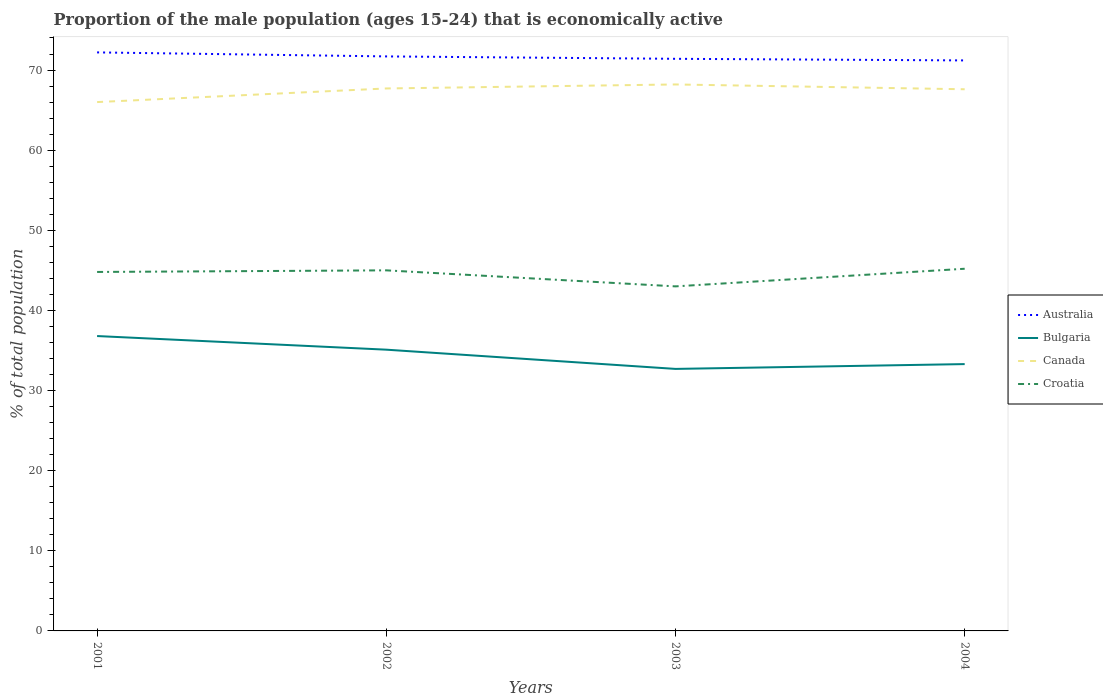How many different coloured lines are there?
Offer a very short reply. 4. Is the number of lines equal to the number of legend labels?
Offer a very short reply. Yes. Across all years, what is the maximum proportion of the male population that is economically active in Australia?
Offer a terse response. 71.2. What is the total proportion of the male population that is economically active in Australia in the graph?
Keep it short and to the point. 0.2. What is the difference between the highest and the second highest proportion of the male population that is economically active in Croatia?
Keep it short and to the point. 2.2. How many lines are there?
Offer a terse response. 4. How many years are there in the graph?
Ensure brevity in your answer.  4. Where does the legend appear in the graph?
Make the answer very short. Center right. What is the title of the graph?
Make the answer very short. Proportion of the male population (ages 15-24) that is economically active. What is the label or title of the X-axis?
Your answer should be very brief. Years. What is the label or title of the Y-axis?
Give a very brief answer. % of total population. What is the % of total population of Australia in 2001?
Give a very brief answer. 72.2. What is the % of total population in Bulgaria in 2001?
Ensure brevity in your answer.  36.8. What is the % of total population of Canada in 2001?
Provide a succinct answer. 66. What is the % of total population of Croatia in 2001?
Make the answer very short. 44.8. What is the % of total population in Australia in 2002?
Ensure brevity in your answer.  71.7. What is the % of total population in Bulgaria in 2002?
Offer a very short reply. 35.1. What is the % of total population in Canada in 2002?
Keep it short and to the point. 67.7. What is the % of total population in Australia in 2003?
Offer a very short reply. 71.4. What is the % of total population in Bulgaria in 2003?
Your answer should be very brief. 32.7. What is the % of total population in Canada in 2003?
Ensure brevity in your answer.  68.2. What is the % of total population in Australia in 2004?
Provide a succinct answer. 71.2. What is the % of total population in Bulgaria in 2004?
Offer a terse response. 33.3. What is the % of total population in Canada in 2004?
Provide a succinct answer. 67.6. What is the % of total population in Croatia in 2004?
Your response must be concise. 45.2. Across all years, what is the maximum % of total population of Australia?
Offer a terse response. 72.2. Across all years, what is the maximum % of total population in Bulgaria?
Offer a terse response. 36.8. Across all years, what is the maximum % of total population in Canada?
Your response must be concise. 68.2. Across all years, what is the maximum % of total population of Croatia?
Keep it short and to the point. 45.2. Across all years, what is the minimum % of total population in Australia?
Give a very brief answer. 71.2. Across all years, what is the minimum % of total population in Bulgaria?
Give a very brief answer. 32.7. Across all years, what is the minimum % of total population in Croatia?
Offer a terse response. 43. What is the total % of total population of Australia in the graph?
Make the answer very short. 286.5. What is the total % of total population in Bulgaria in the graph?
Provide a succinct answer. 137.9. What is the total % of total population in Canada in the graph?
Offer a very short reply. 269.5. What is the total % of total population in Croatia in the graph?
Offer a very short reply. 178. What is the difference between the % of total population in Bulgaria in 2001 and that in 2002?
Keep it short and to the point. 1.7. What is the difference between the % of total population of Canada in 2001 and that in 2002?
Keep it short and to the point. -1.7. What is the difference between the % of total population of Croatia in 2001 and that in 2002?
Give a very brief answer. -0.2. What is the difference between the % of total population in Bulgaria in 2001 and that in 2003?
Give a very brief answer. 4.1. What is the difference between the % of total population of Australia in 2001 and that in 2004?
Your response must be concise. 1. What is the difference between the % of total population in Australia in 2002 and that in 2003?
Offer a very short reply. 0.3. What is the difference between the % of total population in Bulgaria in 2002 and that in 2003?
Your answer should be compact. 2.4. What is the difference between the % of total population in Canada in 2002 and that in 2004?
Give a very brief answer. 0.1. What is the difference between the % of total population of Croatia in 2002 and that in 2004?
Your response must be concise. -0.2. What is the difference between the % of total population in Australia in 2003 and that in 2004?
Offer a terse response. 0.2. What is the difference between the % of total population of Croatia in 2003 and that in 2004?
Your response must be concise. -2.2. What is the difference between the % of total population in Australia in 2001 and the % of total population in Bulgaria in 2002?
Your response must be concise. 37.1. What is the difference between the % of total population in Australia in 2001 and the % of total population in Croatia in 2002?
Make the answer very short. 27.2. What is the difference between the % of total population in Bulgaria in 2001 and the % of total population in Canada in 2002?
Offer a terse response. -30.9. What is the difference between the % of total population in Bulgaria in 2001 and the % of total population in Croatia in 2002?
Provide a succinct answer. -8.2. What is the difference between the % of total population of Australia in 2001 and the % of total population of Bulgaria in 2003?
Offer a terse response. 39.5. What is the difference between the % of total population in Australia in 2001 and the % of total population in Croatia in 2003?
Your answer should be very brief. 29.2. What is the difference between the % of total population of Bulgaria in 2001 and the % of total population of Canada in 2003?
Offer a very short reply. -31.4. What is the difference between the % of total population of Australia in 2001 and the % of total population of Bulgaria in 2004?
Ensure brevity in your answer.  38.9. What is the difference between the % of total population in Australia in 2001 and the % of total population in Croatia in 2004?
Your answer should be compact. 27. What is the difference between the % of total population of Bulgaria in 2001 and the % of total population of Canada in 2004?
Provide a short and direct response. -30.8. What is the difference between the % of total population in Bulgaria in 2001 and the % of total population in Croatia in 2004?
Make the answer very short. -8.4. What is the difference between the % of total population of Canada in 2001 and the % of total population of Croatia in 2004?
Your answer should be compact. 20.8. What is the difference between the % of total population in Australia in 2002 and the % of total population in Bulgaria in 2003?
Give a very brief answer. 39. What is the difference between the % of total population in Australia in 2002 and the % of total population in Croatia in 2003?
Your answer should be compact. 28.7. What is the difference between the % of total population in Bulgaria in 2002 and the % of total population in Canada in 2003?
Give a very brief answer. -33.1. What is the difference between the % of total population in Canada in 2002 and the % of total population in Croatia in 2003?
Give a very brief answer. 24.7. What is the difference between the % of total population in Australia in 2002 and the % of total population in Bulgaria in 2004?
Provide a short and direct response. 38.4. What is the difference between the % of total population of Australia in 2002 and the % of total population of Croatia in 2004?
Give a very brief answer. 26.5. What is the difference between the % of total population of Bulgaria in 2002 and the % of total population of Canada in 2004?
Offer a terse response. -32.5. What is the difference between the % of total population of Bulgaria in 2002 and the % of total population of Croatia in 2004?
Keep it short and to the point. -10.1. What is the difference between the % of total population in Australia in 2003 and the % of total population in Bulgaria in 2004?
Offer a very short reply. 38.1. What is the difference between the % of total population of Australia in 2003 and the % of total population of Canada in 2004?
Your answer should be very brief. 3.8. What is the difference between the % of total population of Australia in 2003 and the % of total population of Croatia in 2004?
Ensure brevity in your answer.  26.2. What is the difference between the % of total population of Bulgaria in 2003 and the % of total population of Canada in 2004?
Your answer should be compact. -34.9. What is the difference between the % of total population of Bulgaria in 2003 and the % of total population of Croatia in 2004?
Give a very brief answer. -12.5. What is the average % of total population of Australia per year?
Your answer should be compact. 71.62. What is the average % of total population in Bulgaria per year?
Provide a succinct answer. 34.48. What is the average % of total population of Canada per year?
Offer a terse response. 67.38. What is the average % of total population in Croatia per year?
Your answer should be very brief. 44.5. In the year 2001, what is the difference between the % of total population in Australia and % of total population in Bulgaria?
Your answer should be compact. 35.4. In the year 2001, what is the difference between the % of total population of Australia and % of total population of Canada?
Keep it short and to the point. 6.2. In the year 2001, what is the difference between the % of total population of Australia and % of total population of Croatia?
Give a very brief answer. 27.4. In the year 2001, what is the difference between the % of total population in Bulgaria and % of total population in Canada?
Provide a succinct answer. -29.2. In the year 2001, what is the difference between the % of total population in Bulgaria and % of total population in Croatia?
Provide a short and direct response. -8. In the year 2001, what is the difference between the % of total population of Canada and % of total population of Croatia?
Make the answer very short. 21.2. In the year 2002, what is the difference between the % of total population in Australia and % of total population in Bulgaria?
Make the answer very short. 36.6. In the year 2002, what is the difference between the % of total population of Australia and % of total population of Canada?
Provide a succinct answer. 4. In the year 2002, what is the difference between the % of total population of Australia and % of total population of Croatia?
Your response must be concise. 26.7. In the year 2002, what is the difference between the % of total population in Bulgaria and % of total population in Canada?
Offer a terse response. -32.6. In the year 2002, what is the difference between the % of total population of Bulgaria and % of total population of Croatia?
Your answer should be very brief. -9.9. In the year 2002, what is the difference between the % of total population of Canada and % of total population of Croatia?
Your response must be concise. 22.7. In the year 2003, what is the difference between the % of total population of Australia and % of total population of Bulgaria?
Your answer should be compact. 38.7. In the year 2003, what is the difference between the % of total population of Australia and % of total population of Croatia?
Ensure brevity in your answer.  28.4. In the year 2003, what is the difference between the % of total population in Bulgaria and % of total population in Canada?
Offer a very short reply. -35.5. In the year 2003, what is the difference between the % of total population in Bulgaria and % of total population in Croatia?
Provide a succinct answer. -10.3. In the year 2003, what is the difference between the % of total population of Canada and % of total population of Croatia?
Provide a short and direct response. 25.2. In the year 2004, what is the difference between the % of total population in Australia and % of total population in Bulgaria?
Ensure brevity in your answer.  37.9. In the year 2004, what is the difference between the % of total population in Australia and % of total population in Canada?
Make the answer very short. 3.6. In the year 2004, what is the difference between the % of total population in Australia and % of total population in Croatia?
Offer a very short reply. 26. In the year 2004, what is the difference between the % of total population of Bulgaria and % of total population of Canada?
Give a very brief answer. -34.3. In the year 2004, what is the difference between the % of total population in Bulgaria and % of total population in Croatia?
Offer a terse response. -11.9. In the year 2004, what is the difference between the % of total population of Canada and % of total population of Croatia?
Provide a succinct answer. 22.4. What is the ratio of the % of total population of Bulgaria in 2001 to that in 2002?
Your answer should be very brief. 1.05. What is the ratio of the % of total population of Canada in 2001 to that in 2002?
Your answer should be very brief. 0.97. What is the ratio of the % of total population in Australia in 2001 to that in 2003?
Offer a terse response. 1.01. What is the ratio of the % of total population of Bulgaria in 2001 to that in 2003?
Your answer should be very brief. 1.13. What is the ratio of the % of total population of Canada in 2001 to that in 2003?
Keep it short and to the point. 0.97. What is the ratio of the % of total population in Croatia in 2001 to that in 2003?
Your answer should be very brief. 1.04. What is the ratio of the % of total population in Australia in 2001 to that in 2004?
Your answer should be compact. 1.01. What is the ratio of the % of total population in Bulgaria in 2001 to that in 2004?
Give a very brief answer. 1.11. What is the ratio of the % of total population in Canada in 2001 to that in 2004?
Make the answer very short. 0.98. What is the ratio of the % of total population in Croatia in 2001 to that in 2004?
Make the answer very short. 0.99. What is the ratio of the % of total population of Australia in 2002 to that in 2003?
Make the answer very short. 1. What is the ratio of the % of total population of Bulgaria in 2002 to that in 2003?
Make the answer very short. 1.07. What is the ratio of the % of total population of Canada in 2002 to that in 2003?
Your answer should be compact. 0.99. What is the ratio of the % of total population of Croatia in 2002 to that in 2003?
Provide a succinct answer. 1.05. What is the ratio of the % of total population of Australia in 2002 to that in 2004?
Provide a succinct answer. 1.01. What is the ratio of the % of total population of Bulgaria in 2002 to that in 2004?
Offer a terse response. 1.05. What is the ratio of the % of total population in Croatia in 2002 to that in 2004?
Your answer should be very brief. 1. What is the ratio of the % of total population of Bulgaria in 2003 to that in 2004?
Provide a succinct answer. 0.98. What is the ratio of the % of total population in Canada in 2003 to that in 2004?
Keep it short and to the point. 1.01. What is the ratio of the % of total population of Croatia in 2003 to that in 2004?
Offer a terse response. 0.95. What is the difference between the highest and the second highest % of total population in Australia?
Provide a short and direct response. 0.5. What is the difference between the highest and the second highest % of total population of Bulgaria?
Keep it short and to the point. 1.7. What is the difference between the highest and the second highest % of total population in Croatia?
Give a very brief answer. 0.2. What is the difference between the highest and the lowest % of total population of Australia?
Your answer should be compact. 1. What is the difference between the highest and the lowest % of total population in Bulgaria?
Keep it short and to the point. 4.1. What is the difference between the highest and the lowest % of total population of Canada?
Provide a succinct answer. 2.2. What is the difference between the highest and the lowest % of total population of Croatia?
Offer a very short reply. 2.2. 